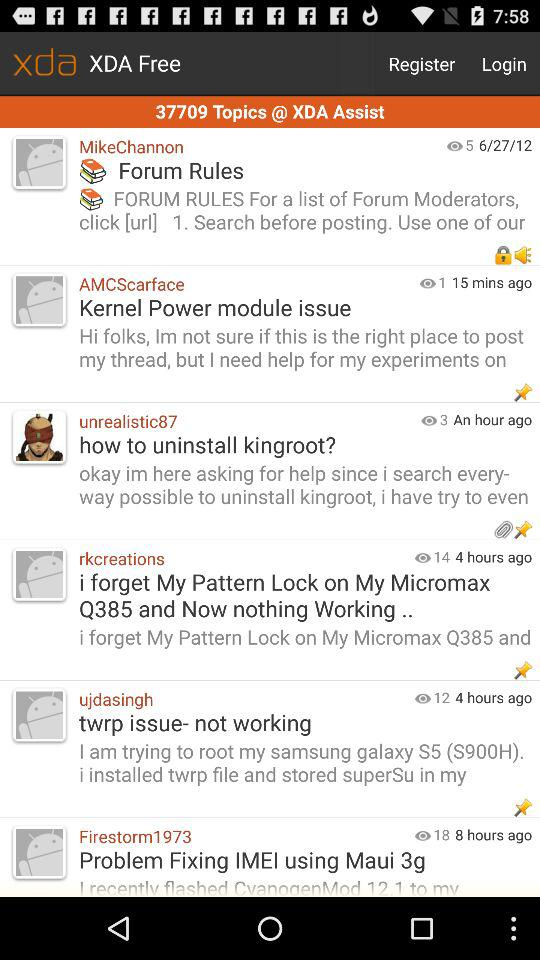How many topics are in the XDA Assist forum?
Answer the question using a single word or phrase. 37709 